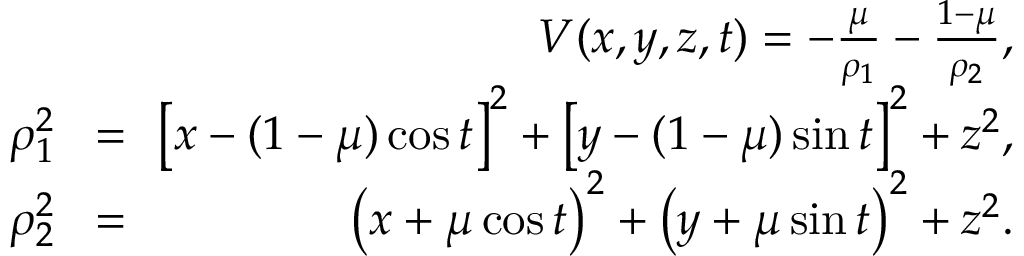<formula> <loc_0><loc_0><loc_500><loc_500>\begin{array} { r l r } & { V ( x , y , z , t ) = - \frac { \mu } { \rho _ { 1 } } - \frac { 1 - \mu } { \rho _ { 2 } } , } \\ { \quad \rho _ { 1 } ^ { 2 } } & { \, = \, } & { { \left [ x - ( 1 - \mu ) \cos { t } \right ] } ^ { 2 } + { \left [ y - ( 1 - \mu ) \sin { t } \right ] } ^ { 2 } + z ^ { 2 } , } \\ { \quad \rho _ { 2 } ^ { 2 } } & { \, = \, } & { { \left ( x + \mu \cos { t } \right ) } ^ { 2 } + { \left ( y + \mu \sin { t } \right ) } ^ { 2 } + z ^ { 2 } . } \end{array}</formula> 